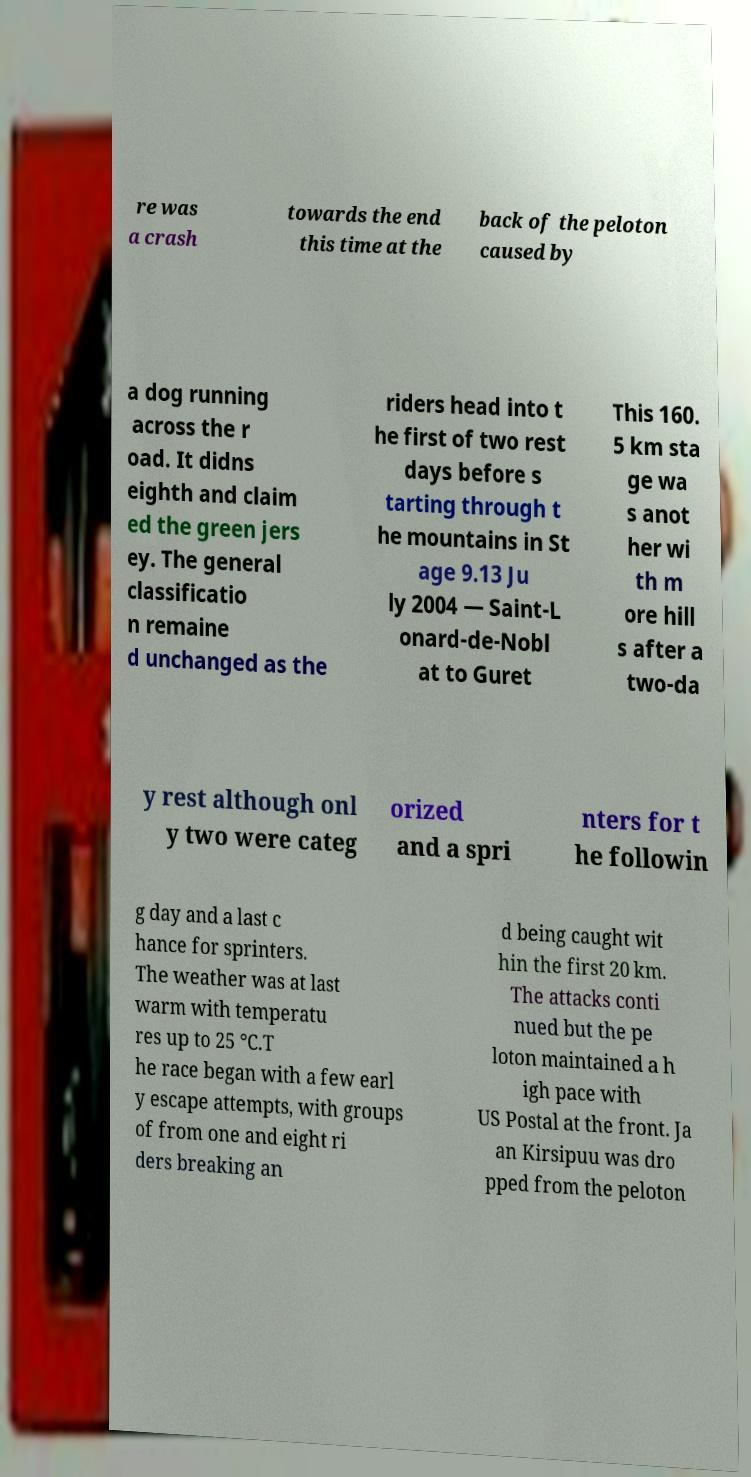I need the written content from this picture converted into text. Can you do that? re was a crash towards the end this time at the back of the peloton caused by a dog running across the r oad. It didns eighth and claim ed the green jers ey. The general classificatio n remaine d unchanged as the riders head into t he first of two rest days before s tarting through t he mountains in St age 9.13 Ju ly 2004 — Saint-L onard-de-Nobl at to Guret This 160. 5 km sta ge wa s anot her wi th m ore hill s after a two-da y rest although onl y two were categ orized and a spri nters for t he followin g day and a last c hance for sprinters. The weather was at last warm with temperatu res up to 25 °C.T he race began with a few earl y escape attempts, with groups of from one and eight ri ders breaking an d being caught wit hin the first 20 km. The attacks conti nued but the pe loton maintained a h igh pace with US Postal at the front. Ja an Kirsipuu was dro pped from the peloton 